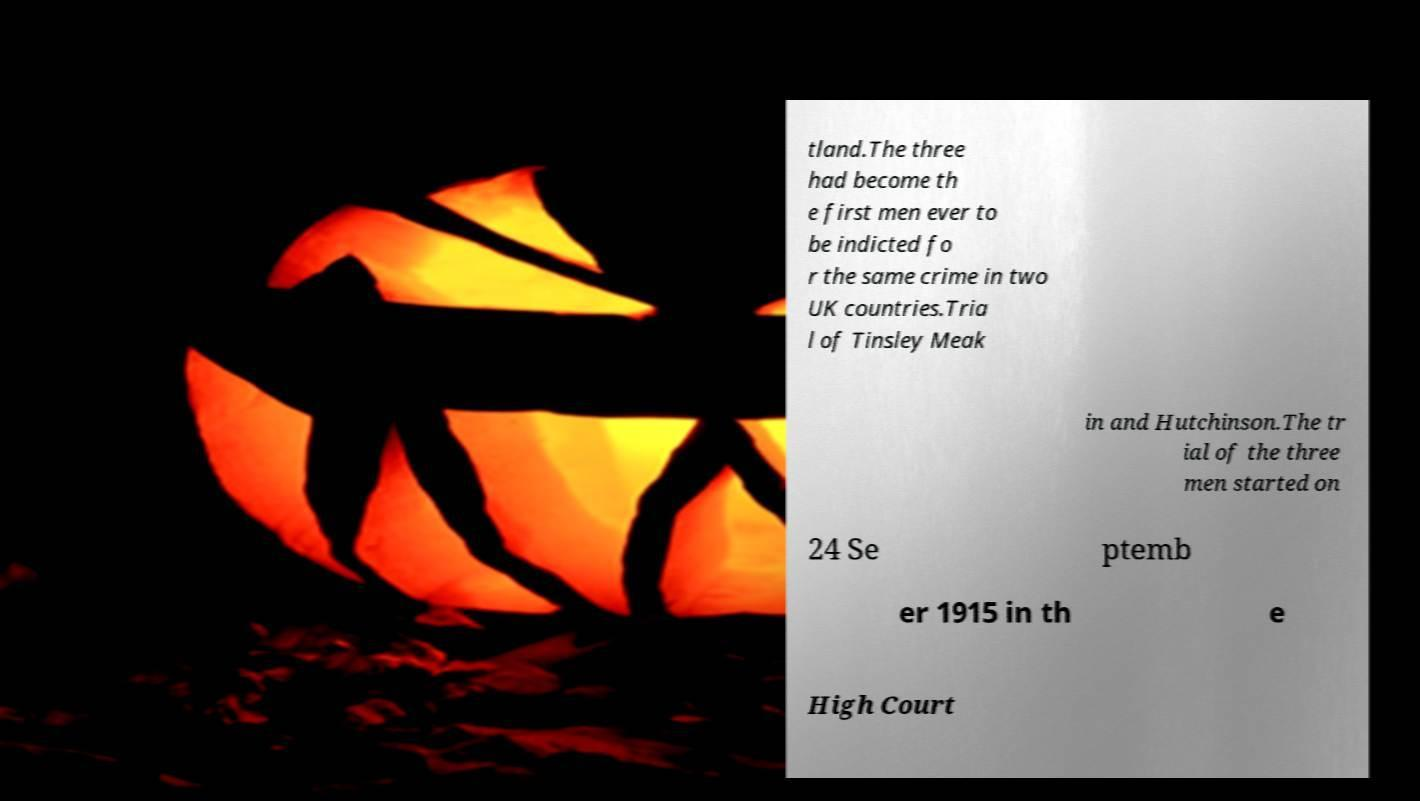I need the written content from this picture converted into text. Can you do that? tland.The three had become th e first men ever to be indicted fo r the same crime in two UK countries.Tria l of Tinsley Meak in and Hutchinson.The tr ial of the three men started on 24 Se ptemb er 1915 in th e High Court 